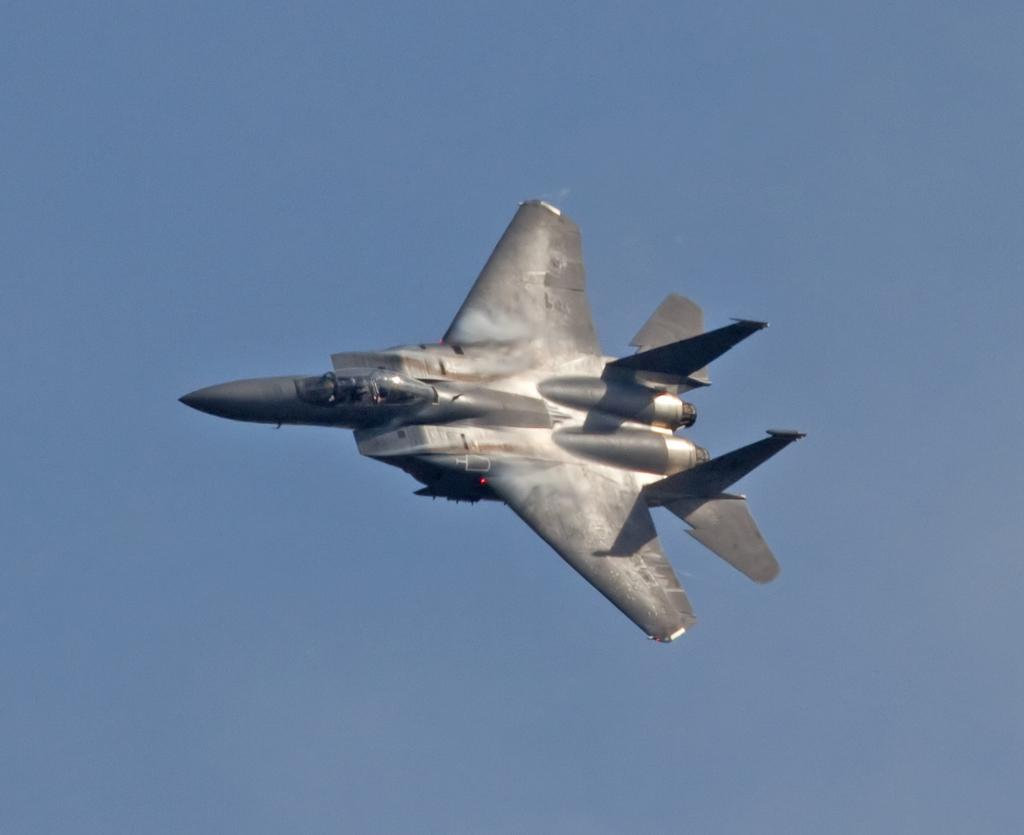What is the main subject of the image? The main subject of the image is an aircraft. What color is the aircraft? The aircraft is black in color. What is the aircraft doing in the image? The aircraft is flying in the air. What can be seen in the background of the image? The sky is visible in the background of the image. Can you tell me how many snakes are coiled around the aircraft in the image? There are no snakes present in the image; the aircraft is flying in the air without any snakes. 